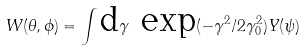<formula> <loc_0><loc_0><loc_500><loc_500>W ( \theta , \phi ) = \int \text {d} \gamma \text { exp} ( - \gamma ^ { 2 } / 2 \gamma ^ { 2 } _ { 0 } ) Y ( \psi )</formula> 